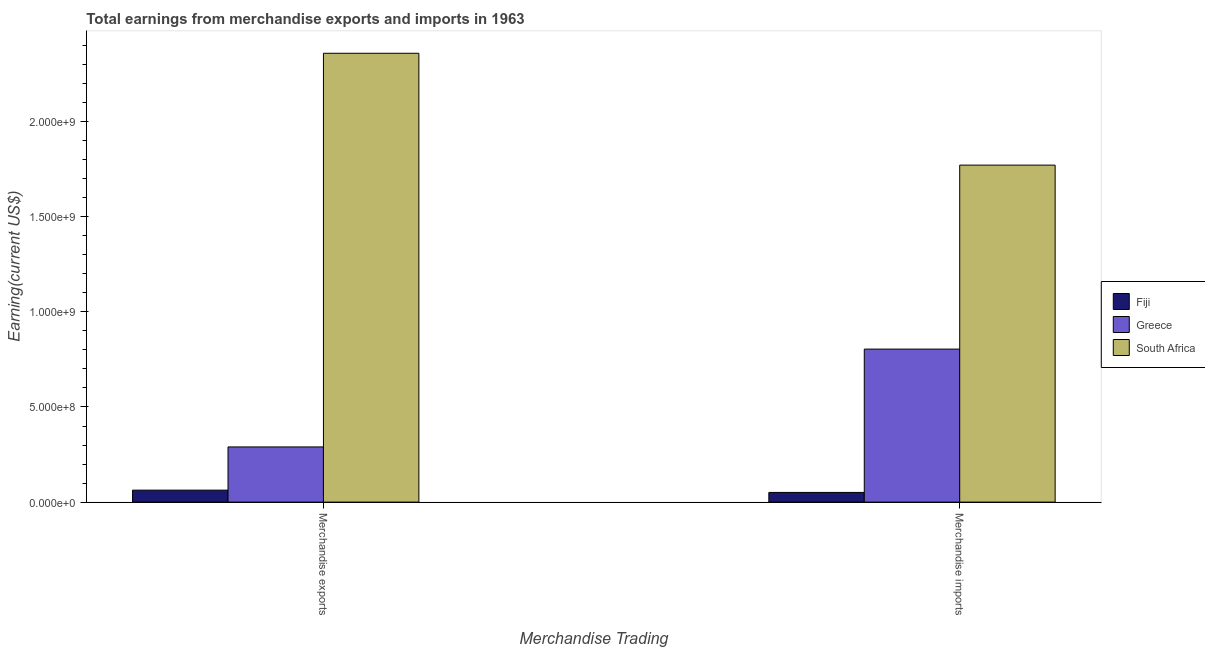Are the number of bars on each tick of the X-axis equal?
Provide a succinct answer. Yes. How many bars are there on the 2nd tick from the right?
Your answer should be compact. 3. What is the earnings from merchandise exports in Greece?
Keep it short and to the point. 2.90e+08. Across all countries, what is the maximum earnings from merchandise exports?
Ensure brevity in your answer.  2.36e+09. Across all countries, what is the minimum earnings from merchandise imports?
Provide a short and direct response. 5.10e+07. In which country was the earnings from merchandise imports maximum?
Give a very brief answer. South Africa. In which country was the earnings from merchandise imports minimum?
Provide a succinct answer. Fiji. What is the total earnings from merchandise exports in the graph?
Provide a short and direct response. 2.71e+09. What is the difference between the earnings from merchandise exports in Greece and that in South Africa?
Your answer should be very brief. -2.07e+09. What is the difference between the earnings from merchandise imports in Fiji and the earnings from merchandise exports in Greece?
Give a very brief answer. -2.39e+08. What is the average earnings from merchandise imports per country?
Provide a succinct answer. 8.76e+08. What is the difference between the earnings from merchandise imports and earnings from merchandise exports in Fiji?
Ensure brevity in your answer.  -1.19e+07. In how many countries, is the earnings from merchandise imports greater than 400000000 US$?
Your answer should be very brief. 2. What is the ratio of the earnings from merchandise imports in Greece to that in South Africa?
Keep it short and to the point. 0.45. Is the earnings from merchandise exports in South Africa less than that in Greece?
Your response must be concise. No. What does the 3rd bar from the left in Merchandise exports represents?
Your response must be concise. South Africa. What does the 1st bar from the right in Merchandise exports represents?
Provide a succinct answer. South Africa. How many bars are there?
Ensure brevity in your answer.  6. What is the difference between two consecutive major ticks on the Y-axis?
Give a very brief answer. 5.00e+08. Does the graph contain any zero values?
Ensure brevity in your answer.  No. Does the graph contain grids?
Provide a short and direct response. No. Where does the legend appear in the graph?
Your response must be concise. Center right. How many legend labels are there?
Keep it short and to the point. 3. How are the legend labels stacked?
Offer a very short reply. Vertical. What is the title of the graph?
Keep it short and to the point. Total earnings from merchandise exports and imports in 1963. What is the label or title of the X-axis?
Your answer should be very brief. Merchandise Trading. What is the label or title of the Y-axis?
Your answer should be compact. Earning(current US$). What is the Earning(current US$) in Fiji in Merchandise exports?
Provide a short and direct response. 6.29e+07. What is the Earning(current US$) in Greece in Merchandise exports?
Offer a very short reply. 2.90e+08. What is the Earning(current US$) of South Africa in Merchandise exports?
Your response must be concise. 2.36e+09. What is the Earning(current US$) in Fiji in Merchandise imports?
Provide a succinct answer. 5.10e+07. What is the Earning(current US$) of Greece in Merchandise imports?
Provide a short and direct response. 8.04e+08. What is the Earning(current US$) in South Africa in Merchandise imports?
Provide a succinct answer. 1.77e+09. Across all Merchandise Trading, what is the maximum Earning(current US$) in Fiji?
Your response must be concise. 6.29e+07. Across all Merchandise Trading, what is the maximum Earning(current US$) of Greece?
Your answer should be very brief. 8.04e+08. Across all Merchandise Trading, what is the maximum Earning(current US$) of South Africa?
Ensure brevity in your answer.  2.36e+09. Across all Merchandise Trading, what is the minimum Earning(current US$) in Fiji?
Provide a short and direct response. 5.10e+07. Across all Merchandise Trading, what is the minimum Earning(current US$) of Greece?
Your response must be concise. 2.90e+08. Across all Merchandise Trading, what is the minimum Earning(current US$) of South Africa?
Give a very brief answer. 1.77e+09. What is the total Earning(current US$) in Fiji in the graph?
Your answer should be compact. 1.14e+08. What is the total Earning(current US$) in Greece in the graph?
Keep it short and to the point. 1.09e+09. What is the total Earning(current US$) of South Africa in the graph?
Provide a succinct answer. 4.13e+09. What is the difference between the Earning(current US$) in Fiji in Merchandise exports and that in Merchandise imports?
Offer a terse response. 1.19e+07. What is the difference between the Earning(current US$) in Greece in Merchandise exports and that in Merchandise imports?
Keep it short and to the point. -5.14e+08. What is the difference between the Earning(current US$) in South Africa in Merchandise exports and that in Merchandise imports?
Provide a succinct answer. 5.88e+08. What is the difference between the Earning(current US$) in Fiji in Merchandise exports and the Earning(current US$) in Greece in Merchandise imports?
Give a very brief answer. -7.41e+08. What is the difference between the Earning(current US$) in Fiji in Merchandise exports and the Earning(current US$) in South Africa in Merchandise imports?
Provide a succinct answer. -1.71e+09. What is the difference between the Earning(current US$) in Greece in Merchandise exports and the Earning(current US$) in South Africa in Merchandise imports?
Your answer should be very brief. -1.48e+09. What is the average Earning(current US$) of Fiji per Merchandise Trading?
Your answer should be compact. 5.69e+07. What is the average Earning(current US$) in Greece per Merchandise Trading?
Make the answer very short. 5.47e+08. What is the average Earning(current US$) of South Africa per Merchandise Trading?
Your answer should be compact. 2.07e+09. What is the difference between the Earning(current US$) of Fiji and Earning(current US$) of Greece in Merchandise exports?
Your answer should be compact. -2.27e+08. What is the difference between the Earning(current US$) of Fiji and Earning(current US$) of South Africa in Merchandise exports?
Make the answer very short. -2.30e+09. What is the difference between the Earning(current US$) of Greece and Earning(current US$) of South Africa in Merchandise exports?
Your answer should be compact. -2.07e+09. What is the difference between the Earning(current US$) in Fiji and Earning(current US$) in Greece in Merchandise imports?
Offer a very short reply. -7.53e+08. What is the difference between the Earning(current US$) of Fiji and Earning(current US$) of South Africa in Merchandise imports?
Give a very brief answer. -1.72e+09. What is the difference between the Earning(current US$) of Greece and Earning(current US$) of South Africa in Merchandise imports?
Your response must be concise. -9.67e+08. What is the ratio of the Earning(current US$) of Fiji in Merchandise exports to that in Merchandise imports?
Give a very brief answer. 1.23. What is the ratio of the Earning(current US$) of Greece in Merchandise exports to that in Merchandise imports?
Provide a short and direct response. 0.36. What is the ratio of the Earning(current US$) in South Africa in Merchandise exports to that in Merchandise imports?
Give a very brief answer. 1.33. What is the difference between the highest and the second highest Earning(current US$) of Fiji?
Make the answer very short. 1.19e+07. What is the difference between the highest and the second highest Earning(current US$) of Greece?
Your response must be concise. 5.14e+08. What is the difference between the highest and the second highest Earning(current US$) in South Africa?
Provide a succinct answer. 5.88e+08. What is the difference between the highest and the lowest Earning(current US$) of Fiji?
Your answer should be compact. 1.19e+07. What is the difference between the highest and the lowest Earning(current US$) in Greece?
Make the answer very short. 5.14e+08. What is the difference between the highest and the lowest Earning(current US$) in South Africa?
Make the answer very short. 5.88e+08. 